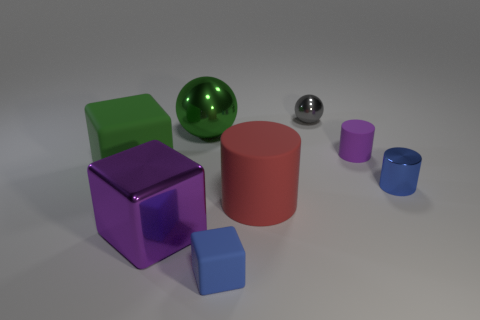There is a large green object that is right of the purple thing that is in front of the tiny rubber object that is on the right side of the tiny gray sphere; what shape is it?
Your answer should be compact. Sphere. Does the rubber cylinder that is behind the red matte cylinder have the same color as the tiny shiny object behind the small purple thing?
Your answer should be very brief. No. Is the number of small matte things that are in front of the big purple metallic thing less than the number of small gray objects in front of the large metal ball?
Offer a very short reply. No. Is there anything else that has the same shape as the big green shiny thing?
Give a very brief answer. Yes. The metallic thing that is the same shape as the big red rubber object is what color?
Give a very brief answer. Blue. There is a big green rubber object; does it have the same shape as the small metal object that is in front of the green rubber cube?
Your answer should be very brief. No. How many objects are either large shiny objects that are in front of the big green rubber thing or cylinders in front of the purple rubber cylinder?
Offer a very short reply. 3. What is the material of the red object?
Give a very brief answer. Rubber. How many other objects are there of the same size as the shiny cube?
Make the answer very short. 3. There is a ball behind the big ball; how big is it?
Give a very brief answer. Small. 